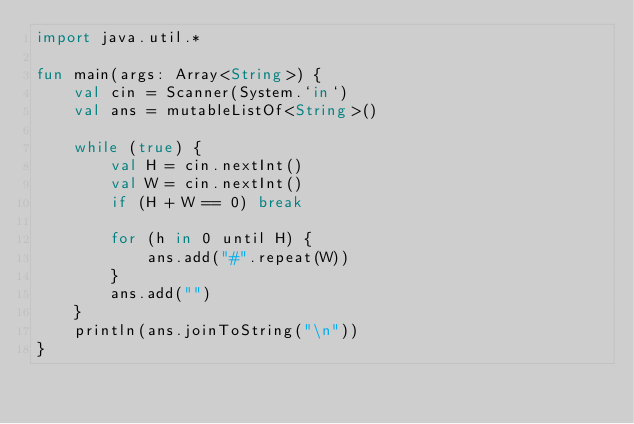Convert code to text. <code><loc_0><loc_0><loc_500><loc_500><_Kotlin_>import java.util.*

fun main(args: Array<String>) {
	val cin = Scanner(System.`in`)
	val ans = mutableListOf<String>()

	while (true) {
		val H = cin.nextInt()
		val W = cin.nextInt()
		if (H + W == 0) break

		for (h in 0 until H) {
			ans.add("#".repeat(W))
		}
		ans.add("")
	}
	println(ans.joinToString("\n"))
}

</code> 